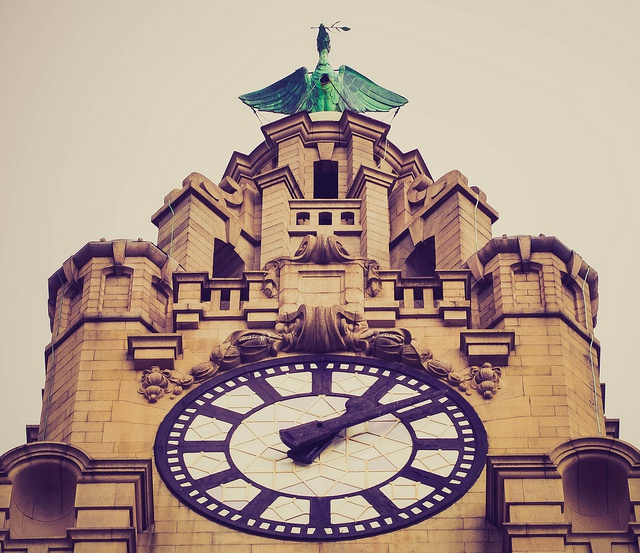Describe the objects in this image and their specific colors. I can see a clock in tan, beige, purple, and navy tones in this image. 